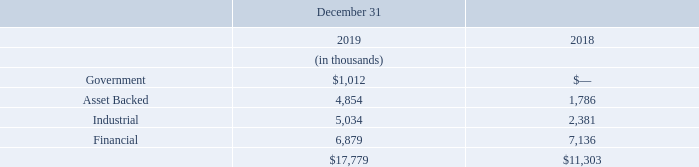NOTE 3 - SHORT TERM INVESTMENTS
The Company's short term investments are classified as below with maturities of twelve months or less, unrealized gains and losses were immaterial for the periods presented:
What are the respective values of the company's asset-backed short term investments in 2018 and 2019 respectively?
Answer scale should be: thousand. 1,786, 4,854. What are the respective values of the company's industrial short term investments in 2018 and 2019 respectively?
Answer scale should be: thousand. 2,381, 5,034. What are the respective values of the company's financial short term investments in 2018 and 2019 respectively?
Answer scale should be: thousand. 7,136, 6,879. What is the percentage change in the company's asset-backed short term investments between 2018 and 2019?
Answer scale should be: percent. (4,854 - 1,786)/1,786 
Answer: 171.78. What is the percentage change in the company's industrial short term investments between 2018 and 2019?
Answer scale should be: percent. (5,034-2,381)/2,381 
Answer: 111.42. What is the percentage change in the company's financial short term investments between 2018 and 2019?
Answer scale should be: percent. (6,879 - 7,136)/7,136 
Answer: -3.6. 